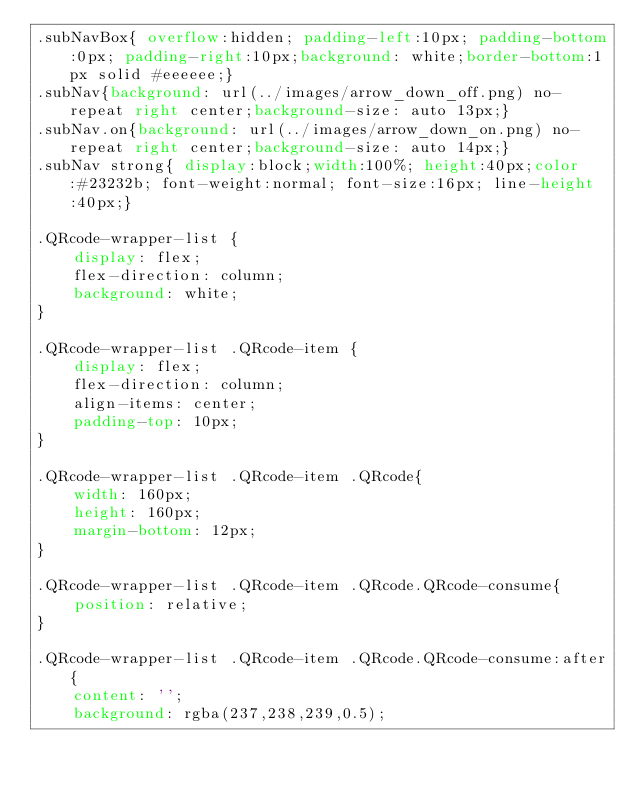<code> <loc_0><loc_0><loc_500><loc_500><_CSS_>.subNavBox{ overflow:hidden; padding-left:10px; padding-bottom:0px; padding-right:10px;background: white;border-bottom:1px solid #eeeeee;}
.subNav{background: url(../images/arrow_down_off.png) no-repeat right center;background-size: auto 13px;}
.subNav.on{background: url(../images/arrow_down_on.png) no-repeat right center;background-size: auto 14px;}
.subNav strong{ display:block;width:100%; height:40px;color:#23232b; font-weight:normal; font-size:16px; line-height:40px;}

.QRcode-wrapper-list {
    display: flex;
    flex-direction: column;
    background: white;
}

.QRcode-wrapper-list .QRcode-item {
    display: flex;
    flex-direction: column;
    align-items: center;
    padding-top: 10px;
}

.QRcode-wrapper-list .QRcode-item .QRcode{
    width: 160px;
    height: 160px;
    margin-bottom: 12px;
}

.QRcode-wrapper-list .QRcode-item .QRcode.QRcode-consume{
    position: relative;
}

.QRcode-wrapper-list .QRcode-item .QRcode.QRcode-consume:after{
    content: '';
    background: rgba(237,238,239,0.5);</code> 